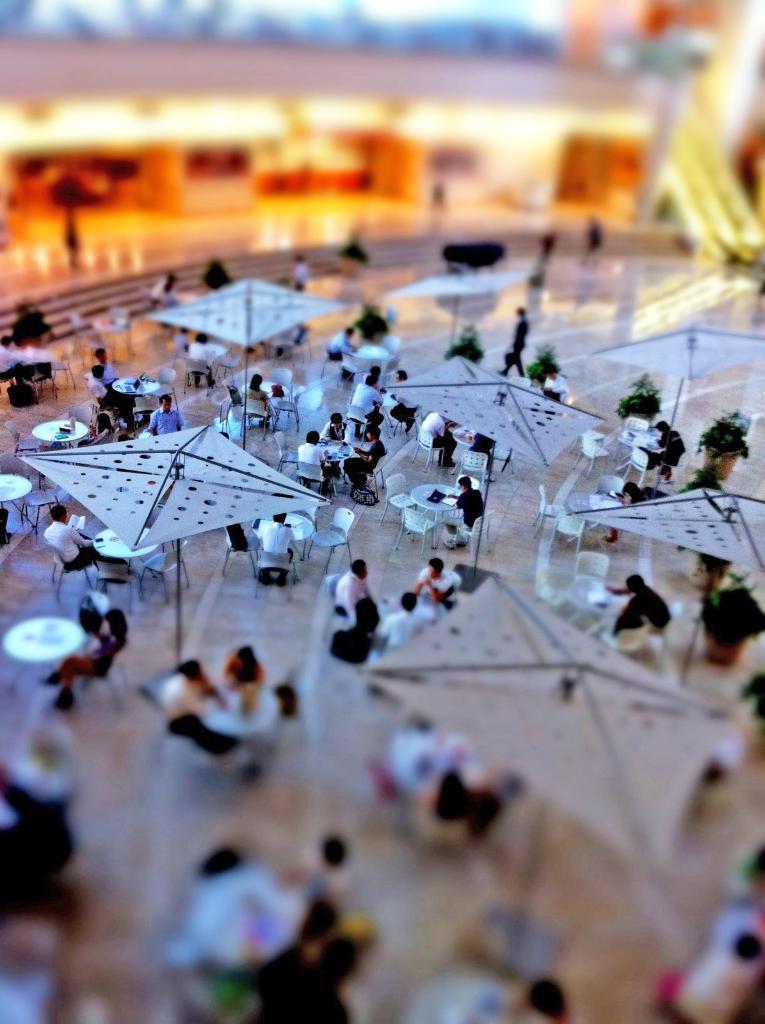Describe this image in one or two sentences. In this picture, we see many people are sitting on the chairs around the tables. There are many chairs and tables. They are sitting under the white tents. Behind them, we see the staircase and a building. This picture is blurred in the background. At the bottom of the picture, it is blurred. 